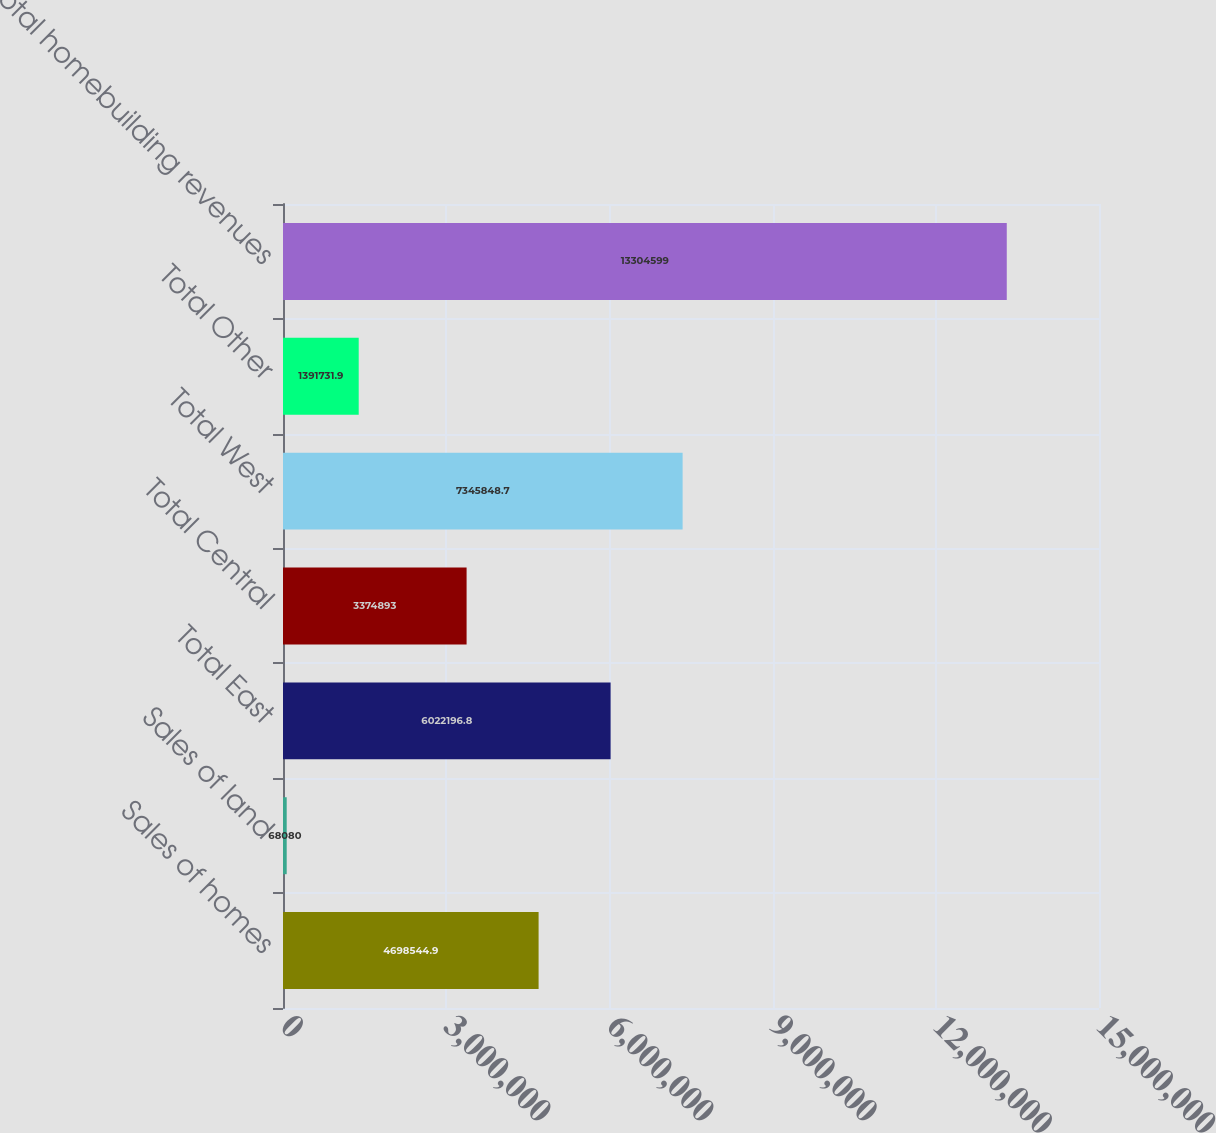<chart> <loc_0><loc_0><loc_500><loc_500><bar_chart><fcel>Sales of homes<fcel>Sales of land<fcel>Total East<fcel>Total Central<fcel>Total West<fcel>Total Other<fcel>Total homebuilding revenues<nl><fcel>4.69854e+06<fcel>68080<fcel>6.0222e+06<fcel>3.37489e+06<fcel>7.34585e+06<fcel>1.39173e+06<fcel>1.33046e+07<nl></chart> 